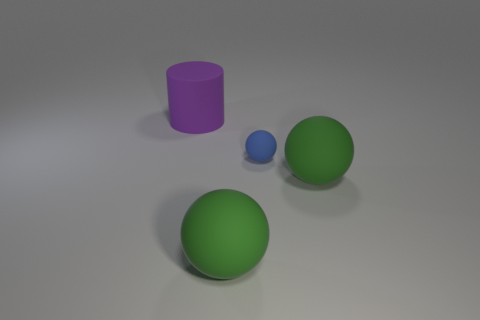The purple matte thing is what size?
Give a very brief answer. Large. How many green balls are to the left of the tiny matte object?
Your response must be concise. 1. There is a green sphere to the right of the large green matte thing on the left side of the blue matte ball; how big is it?
Your answer should be compact. Large. Does the large rubber object to the right of the tiny rubber sphere have the same shape as the large purple rubber thing behind the blue matte sphere?
Your answer should be very brief. No. There is a large matte thing behind the large green ball to the right of the small object; what is its shape?
Give a very brief answer. Cylinder. There is a thing that is both to the left of the small blue matte thing and in front of the large cylinder; how big is it?
Provide a short and direct response. Large. There is a large purple object; is it the same shape as the big green thing on the left side of the small blue thing?
Give a very brief answer. No. There is a cylinder; is it the same color as the large object to the right of the blue matte thing?
Offer a very short reply. No. How many other objects are there of the same size as the blue matte object?
Your answer should be compact. 0. The matte thing on the left side of the big ball that is in front of the green matte sphere to the right of the small ball is what shape?
Provide a short and direct response. Cylinder. 